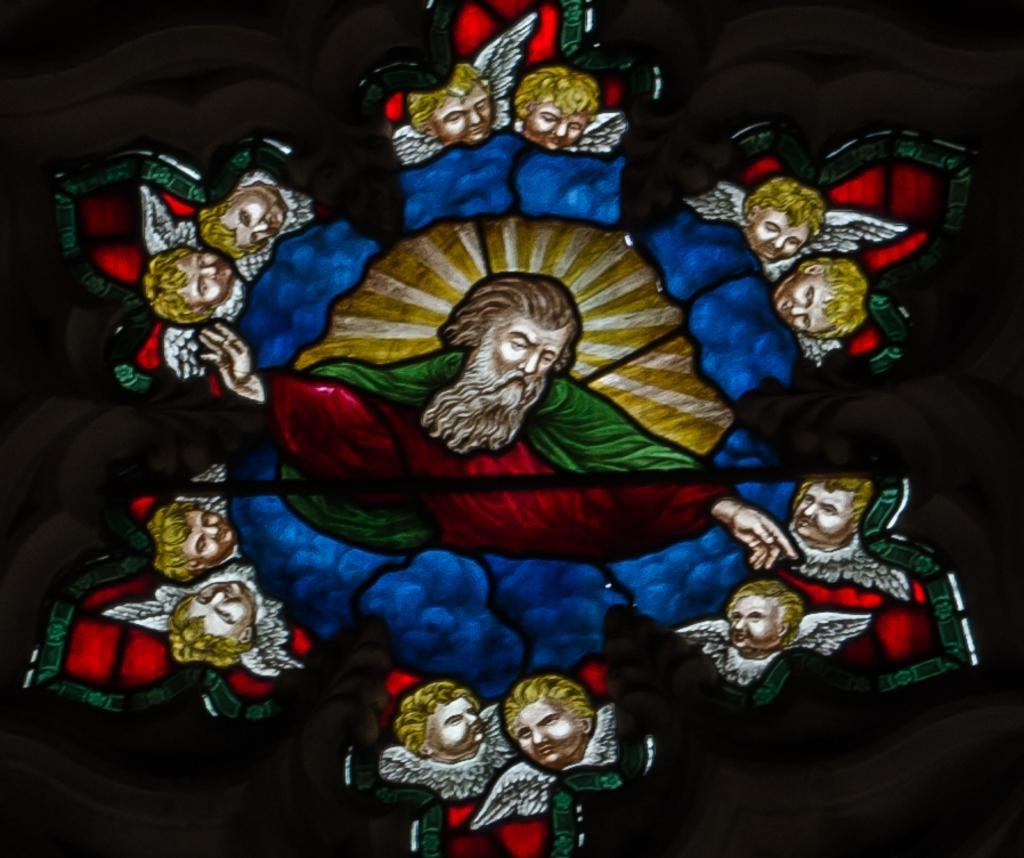What type of artwork is depicted in the image? The image appears to be a frame or a painting. Where is the artwork located in relation to the window? The frame or painting is placed over a window. What is the subject matter of the artwork? The image features people's faces with wings. How can you describe the edges of the image? The edges of the image are dark. How many snails can be seen crawling on the people's faces with wings in the image? There are no snails present in the image; it features people's faces with wings. Is there a rifle visible in the image? There is no rifle present in the image. 